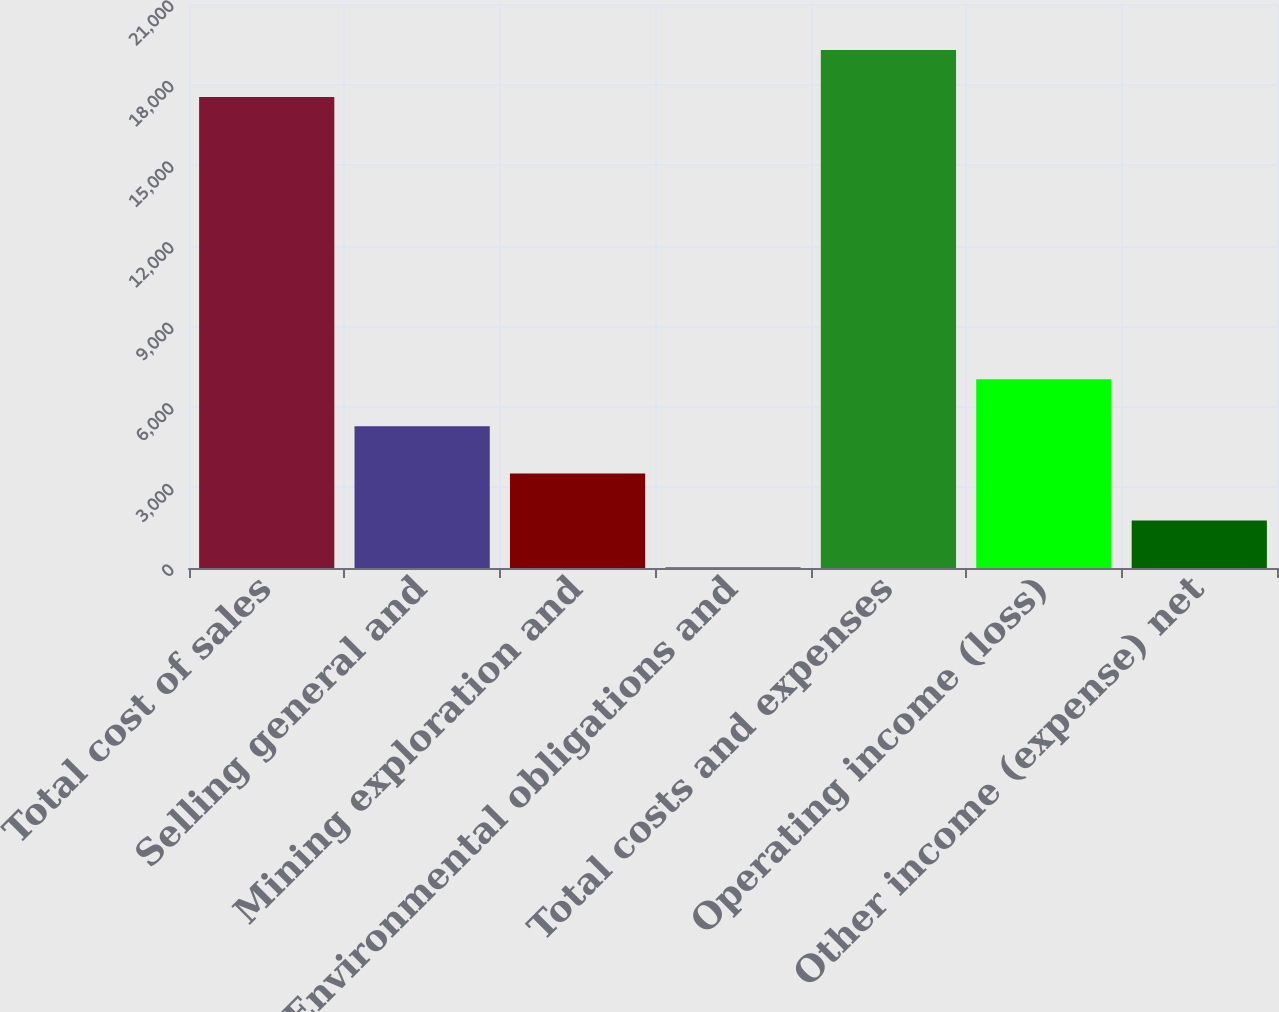Convert chart to OTSL. <chart><loc_0><loc_0><loc_500><loc_500><bar_chart><fcel>Total cost of sales<fcel>Selling general and<fcel>Mining exploration and<fcel>Environmental obligations and<fcel>Total costs and expenses<fcel>Operating income (loss)<fcel>Other income (expense) net<nl><fcel>17534<fcel>5277.5<fcel>3523<fcel>14<fcel>19288.5<fcel>7032<fcel>1768.5<nl></chart> 